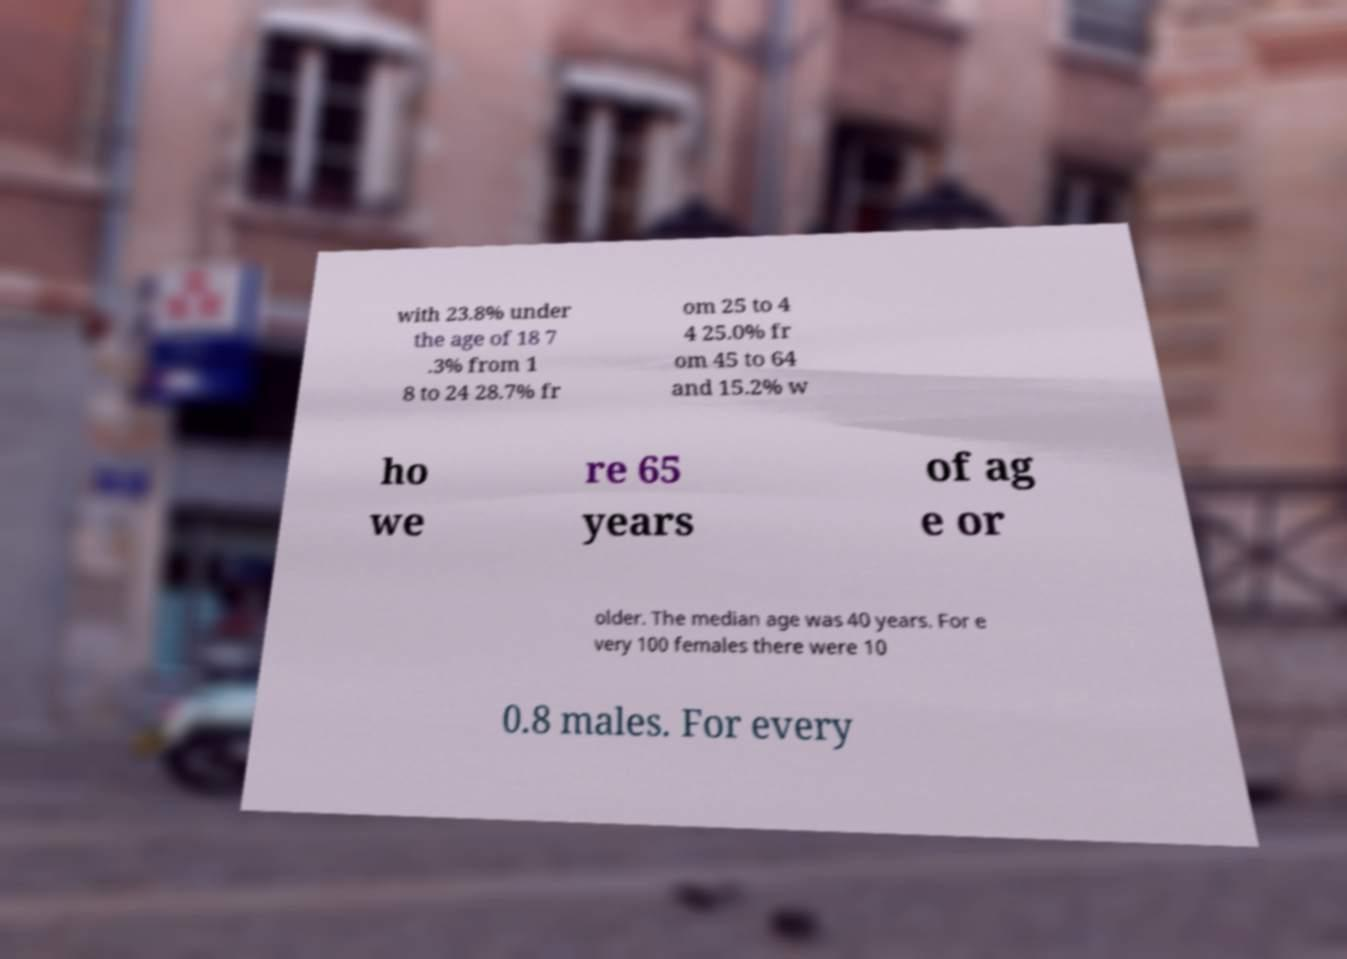Could you assist in decoding the text presented in this image and type it out clearly? with 23.8% under the age of 18 7 .3% from 1 8 to 24 28.7% fr om 25 to 4 4 25.0% fr om 45 to 64 and 15.2% w ho we re 65 years of ag e or older. The median age was 40 years. For e very 100 females there were 10 0.8 males. For every 